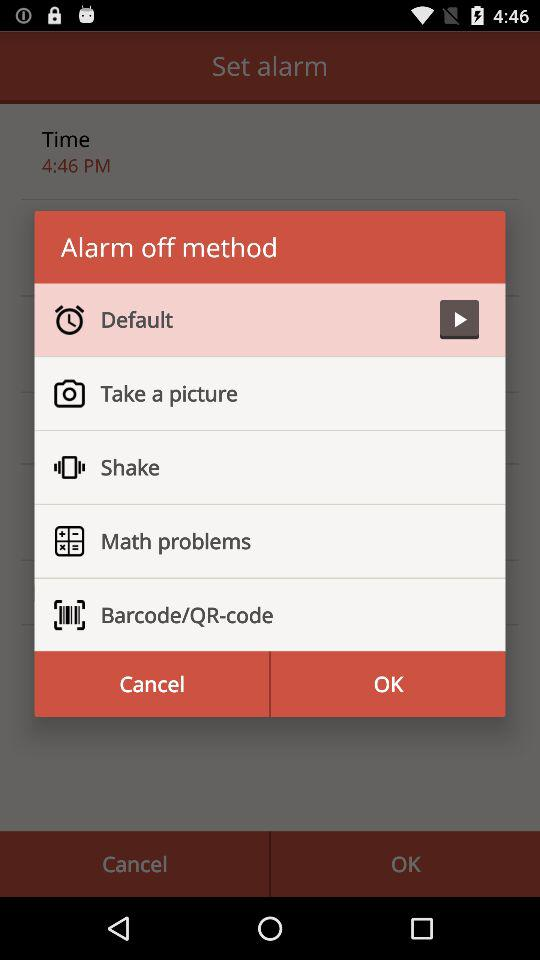Which option has a "Play" button? The option is "Default". 